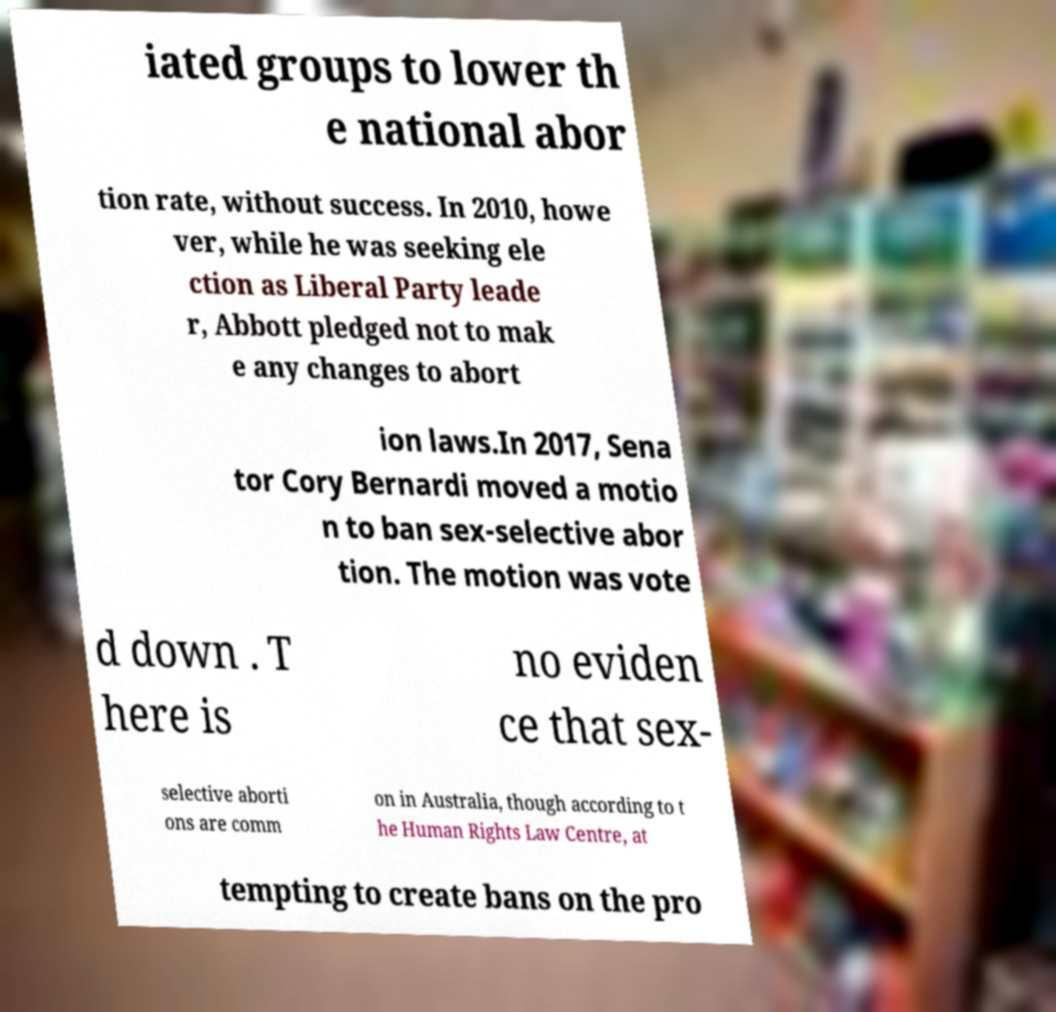Please identify and transcribe the text found in this image. iated groups to lower th e national abor tion rate, without success. In 2010, howe ver, while he was seeking ele ction as Liberal Party leade r, Abbott pledged not to mak e any changes to abort ion laws.In 2017, Sena tor Cory Bernardi moved a motio n to ban sex-selective abor tion. The motion was vote d down . T here is no eviden ce that sex- selective aborti ons are comm on in Australia, though according to t he Human Rights Law Centre, at tempting to create bans on the pro 